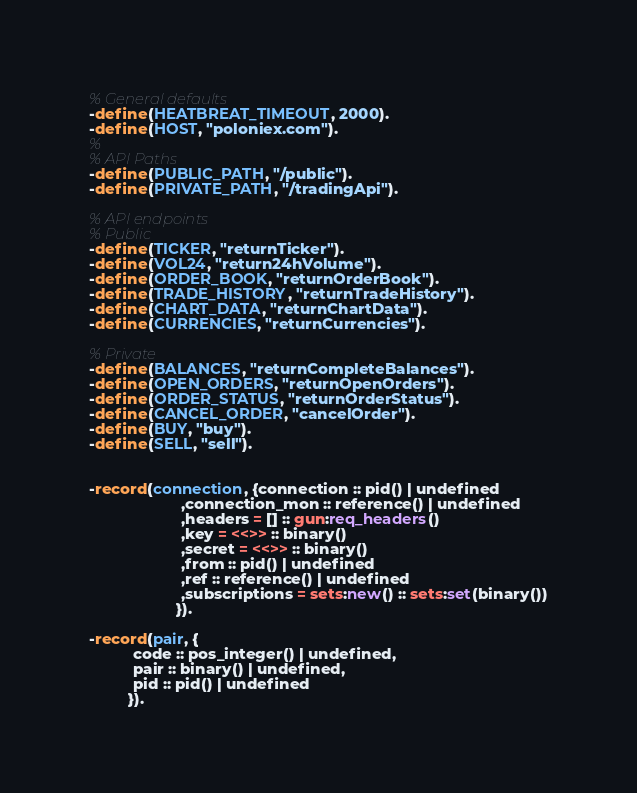<code> <loc_0><loc_0><loc_500><loc_500><_Erlang_>% General defaults
-define(HEATBREAT_TIMEOUT, 2000).
-define(HOST, "poloniex.com").
%
% API Paths
-define(PUBLIC_PATH, "/public").
-define(PRIVATE_PATH, "/tradingApi").

% API endpoints
% Public
-define(TICKER, "returnTicker").
-define(VOL24, "return24hVolume").
-define(ORDER_BOOK, "returnOrderBook").
-define(TRADE_HISTORY, "returnTradeHistory").
-define(CHART_DATA, "returnChartData").
-define(CURRENCIES, "returnCurrencies").

% Private
-define(BALANCES, "returnCompleteBalances").
-define(OPEN_ORDERS, "returnOpenOrders").
-define(ORDER_STATUS, "returnOrderStatus").
-define(CANCEL_ORDER, "cancelOrder").
-define(BUY, "buy").
-define(SELL, "sell").


-record(connection, {connection :: pid() | undefined
                     ,connection_mon :: reference() | undefined
                     ,headers = [] :: gun:req_headers()
                     ,key = <<>> :: binary()
                     ,secret = <<>> :: binary()
                     ,from :: pid() | undefined
                     ,ref :: reference() | undefined
                     ,subscriptions = sets:new() :: sets:set(binary())
                    }).

-record(pair, {
          code :: pos_integer() | undefined,
          pair :: binary() | undefined,
          pid :: pid() | undefined
         }).

</code> 